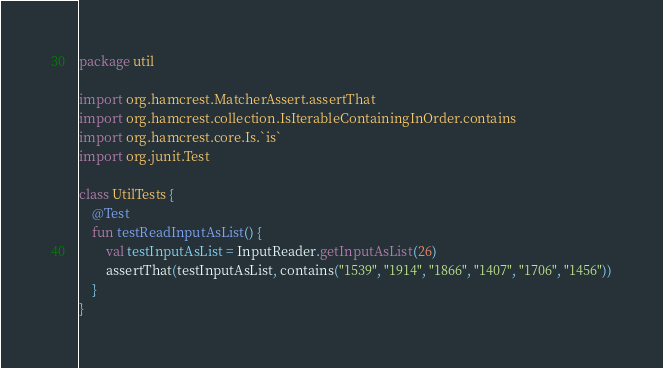Convert code to text. <code><loc_0><loc_0><loc_500><loc_500><_Kotlin_>package util

import org.hamcrest.MatcherAssert.assertThat
import org.hamcrest.collection.IsIterableContainingInOrder.contains
import org.hamcrest.core.Is.`is`
import org.junit.Test

class UtilTests {
    @Test
    fun testReadInputAsList() {
        val testInputAsList = InputReader.getInputAsList(26)
        assertThat(testInputAsList, contains("1539", "1914", "1866", "1407", "1706", "1456"))
    }
}
</code> 